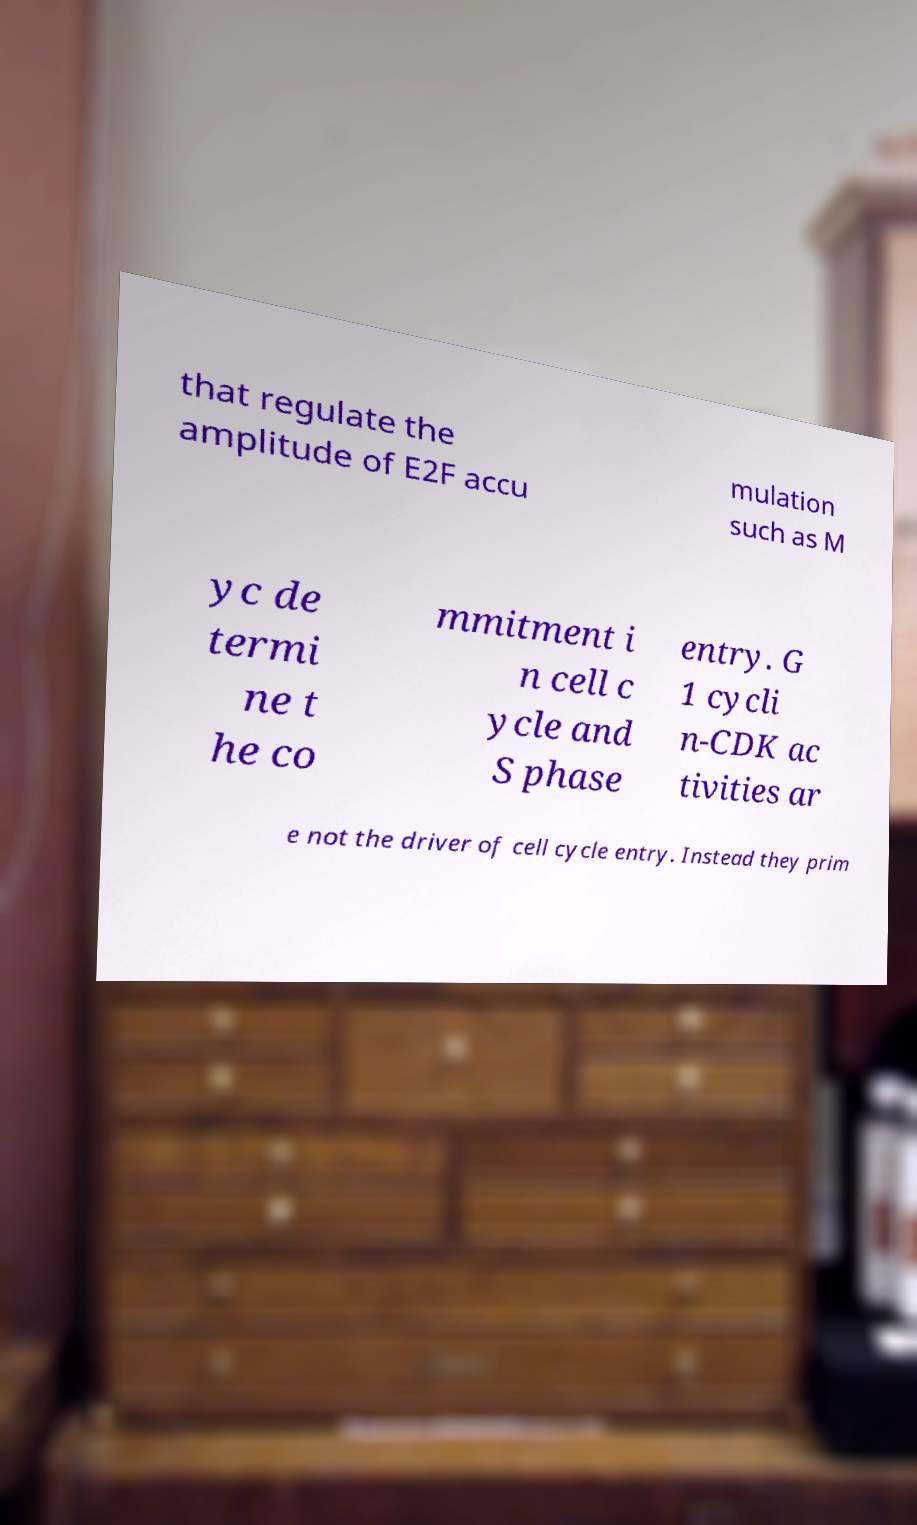I need the written content from this picture converted into text. Can you do that? that regulate the amplitude of E2F accu mulation such as M yc de termi ne t he co mmitment i n cell c ycle and S phase entry. G 1 cycli n-CDK ac tivities ar e not the driver of cell cycle entry. Instead they prim 